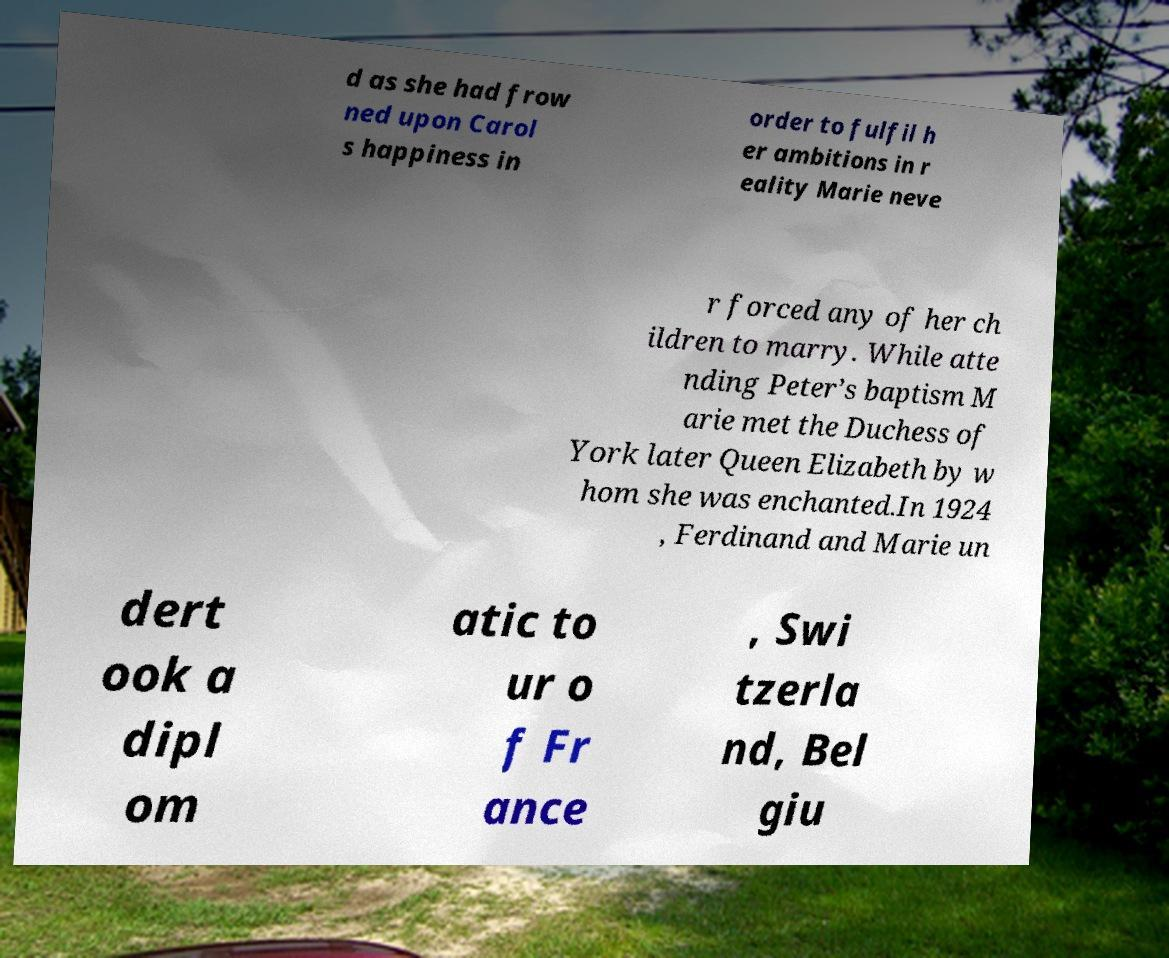I need the written content from this picture converted into text. Can you do that? d as she had frow ned upon Carol s happiness in order to fulfil h er ambitions in r eality Marie neve r forced any of her ch ildren to marry. While atte nding Peter’s baptism M arie met the Duchess of York later Queen Elizabeth by w hom she was enchanted.In 1924 , Ferdinand and Marie un dert ook a dipl om atic to ur o f Fr ance , Swi tzerla nd, Bel giu 